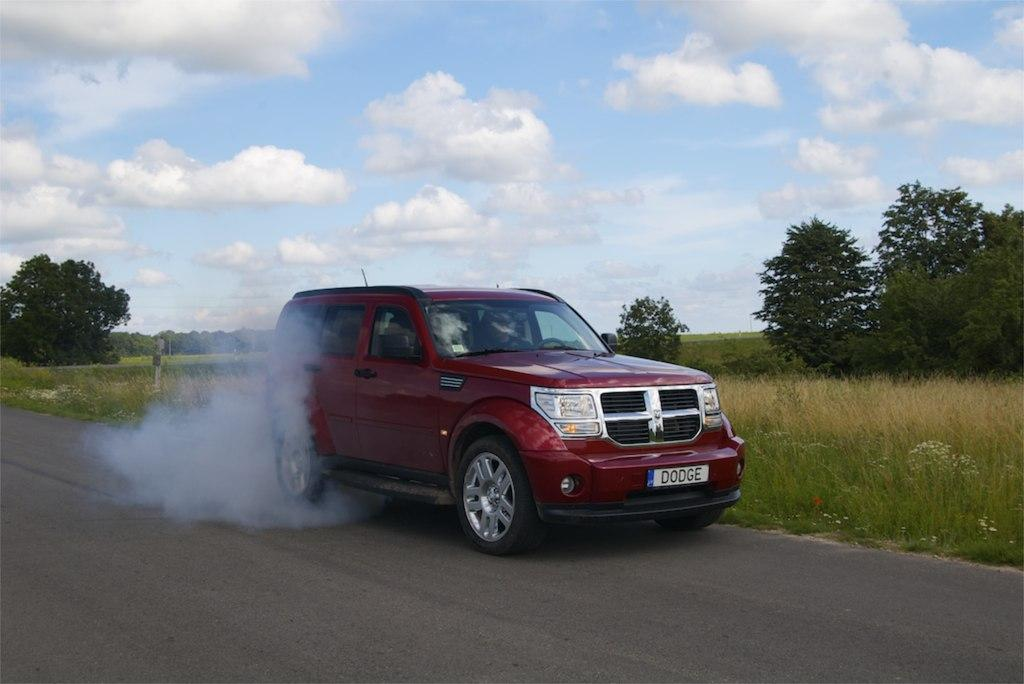What is on the road in the image? There is a vehicle on the road in the image. What is coming out from the vehicle? Snow is visible coming out from the vehicle. What type of vegetation is near the side of the road? There are trees near the side of the road. What type of ground cover is present near the side of the road? Grass is present near the side of the road. What type of rock is being rubbed by the vehicle in the image? There is no rock present in the image, and the vehicle is not rubbing against anything. 